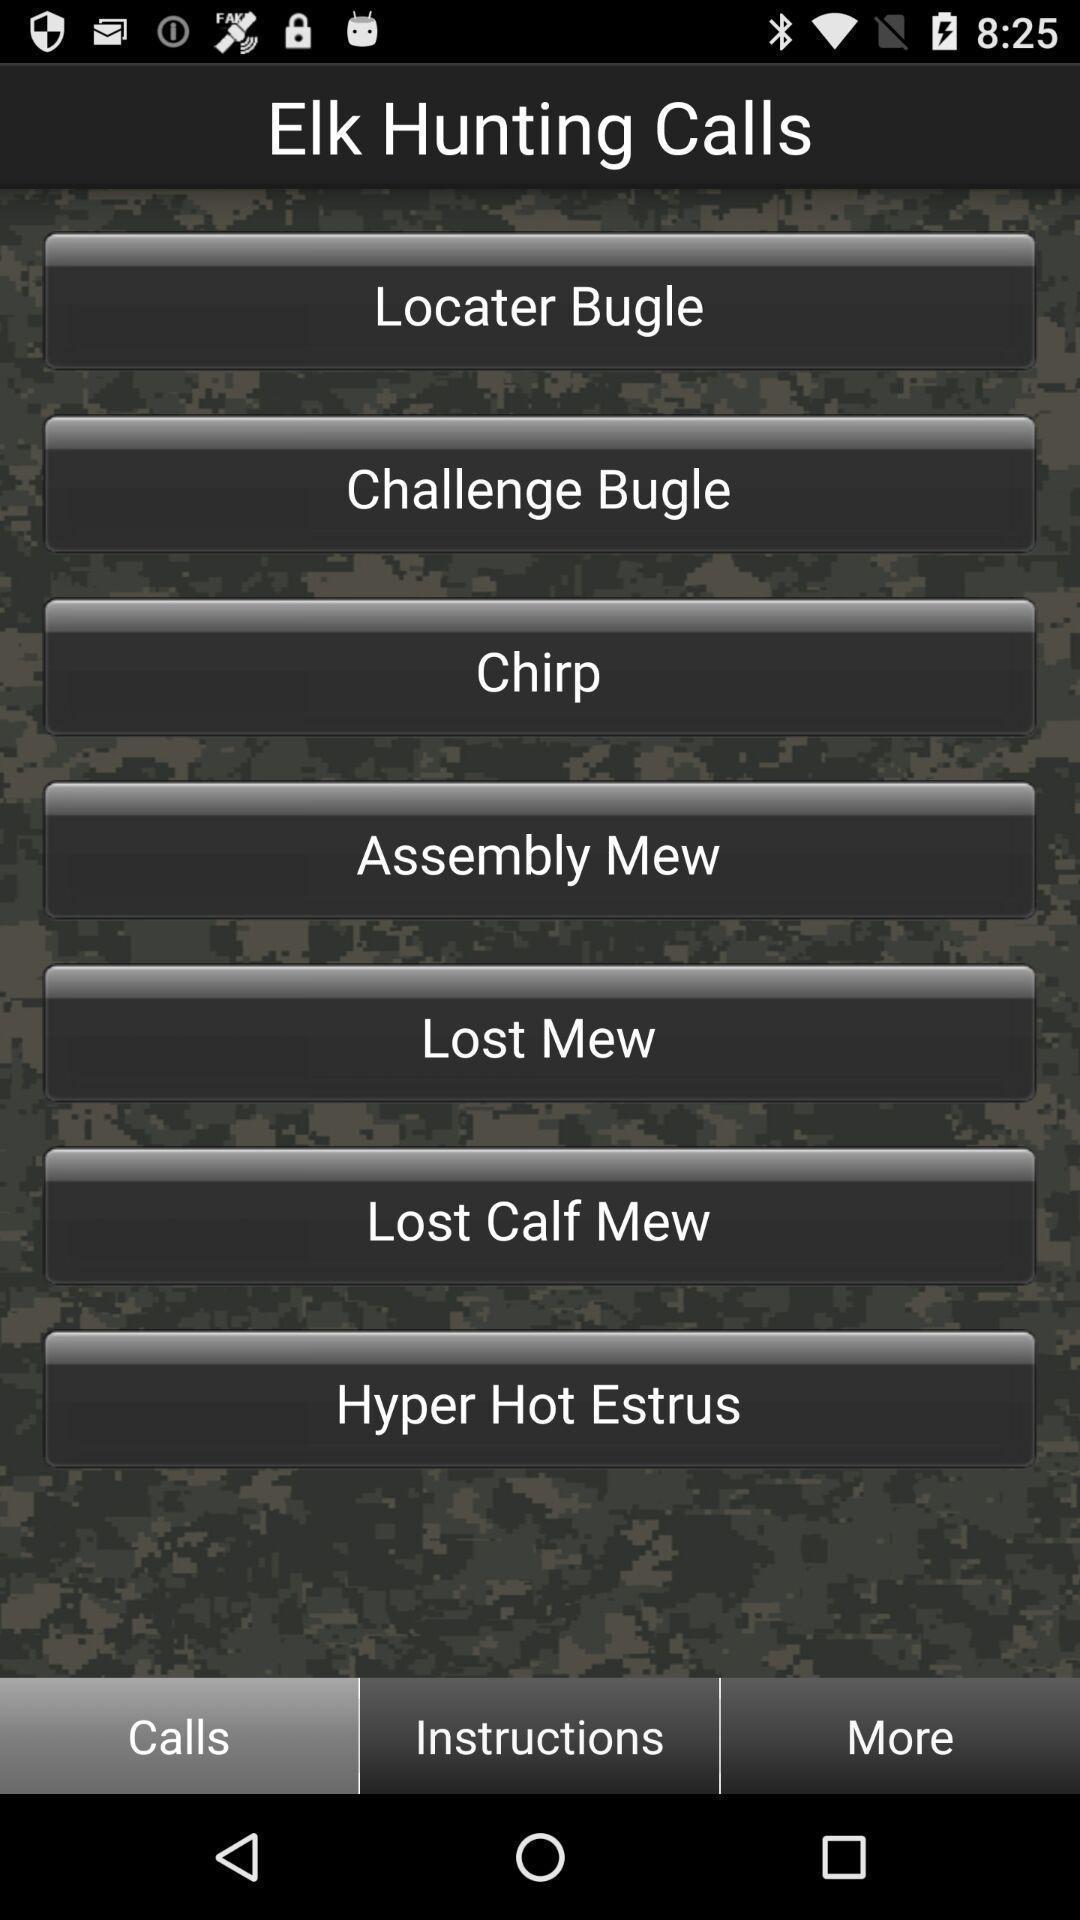Summarize the main components in this picture. Page showing the options in calling app. 